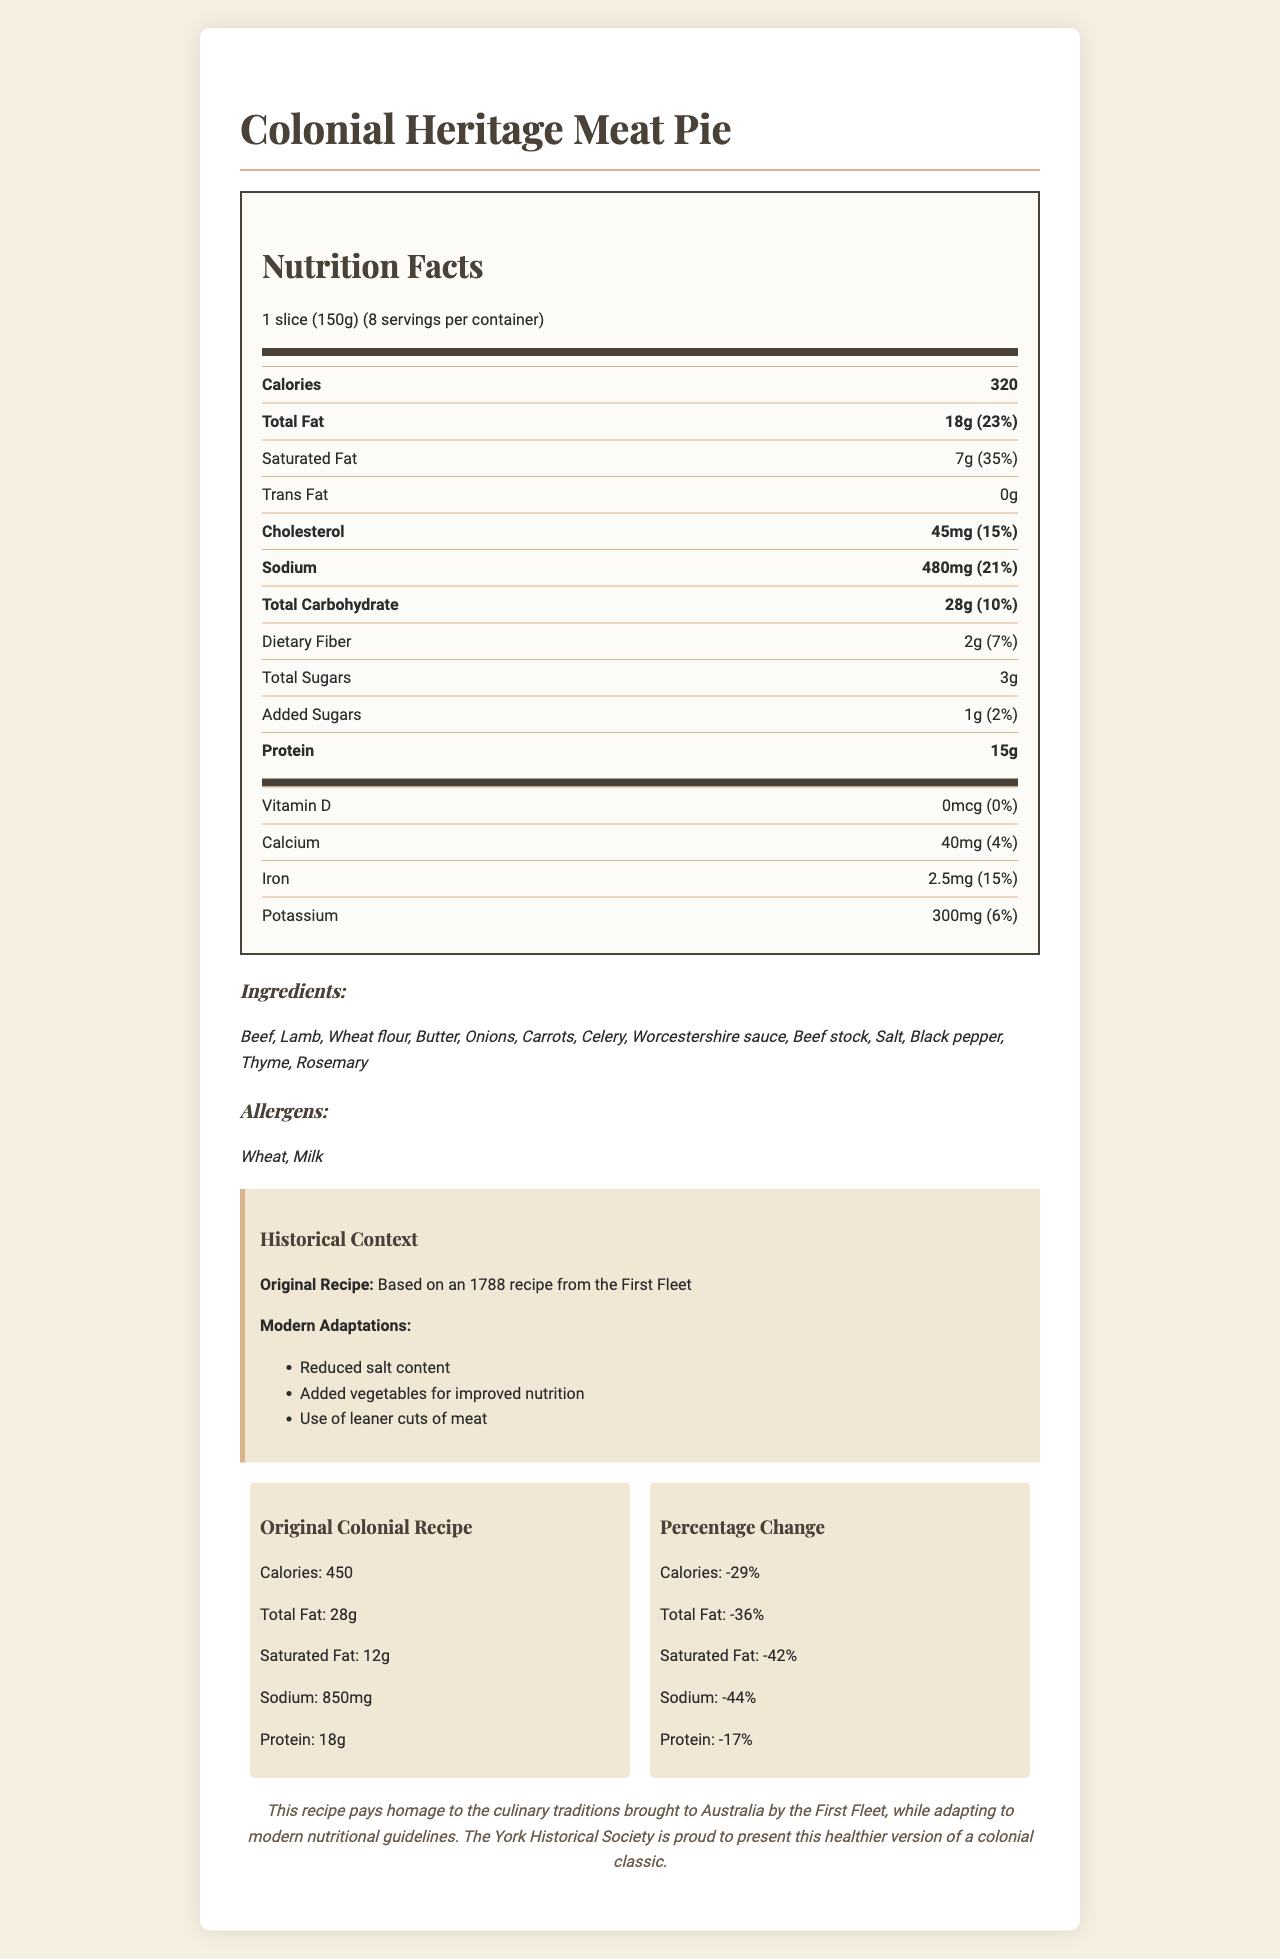what is the serving size of the Colonial Heritage Meat Pie? The serving size is stated as "1 slice (150g)" under the Nutrition Facts heading.
Answer: 1 slice (150g) how many calories are in one serving of the Colonial Heritage Meat Pie? The calories per serving are listed as 320 under the Calories section in the Nutrition Facts.
Answer: 320 how much total fat is in one serving, and what percentage of the daily value does it represent? The Total Fat section of the Nutrition Facts says there are 18g of total fat, which is 23% of the daily value.
Answer: 18g, 23% what is the amount of sodium per serving? The sodium amount is listed as 480mg under the Sodium section in the Nutrition Facts.
Answer: 480mg how much protein is in one serving? The amount of protein per serving is provided as 15g under the Protein section in the Nutrition Facts.
Answer: 15g which of the following modern adaptations were made to the original recipe? A. Increased salt content B. Added vegetables C. Use of fattier cuts of meat The Modern Adaptations section lists "Added vegetables for improved nutrition" as one of the adaptations.
Answer: B how much iron is in one serving of the meat pie? A. 4mg B. 2.5mg C. 10mg The Nutrition Facts show that one serving has 2.5mg of iron.
Answer: B is the new version of the meat pie higher or lower in calories compared to the original colonial recipe? The Comparative Nutrition section states that the original recipe had 450 calories compared to the current recipe's 320 calories, indicating a reduction.
Answer: Lower are there any allergens listed in the ingredients of the Colonial Heritage Meat Pie? The Allergens section lists "Wheat" and "Milk" as allergens in the meat pie.
Answer: Yes summarize the main idea of the document. The document provides comprehensive details about the Colonial Heritage Meat Pie including its nutrition facts, ingredients, historical context, and adaptations made to align with modern nutritional guidelines. It highlights the changes made from the original 1788 recipe, resulting in a pie with lower calories, fats, and sodium.
Answer: The document details the nutritional information for a modern adaptation of a colonial-era meat pie, listing its nutritional content, ingredients, allergens, historical context, and a comparison with the original recipe. what are the three main modern adaptations made to the original recipe? The Historical Context section specifies these three adaptations under Modern Adaptations.
Answer: Reduced salt content, added vegetables for improved nutrition, use of leaner cuts of meat how much lower is the sodium content in the modern meat pie compared to the original recipe, in percentage terms? The Percentage Change section in the Comparative Nutrition reveals a 44% reduction in sodium content.
Answer: 44% how many servings are there in one container of the Colonial Heritage Meat Pie? The document mentions that there are 8 servings per container.
Answer: 8 what is the total carbohydrate content per serving, and what percentage of the daily value does it represent? The Total Carbohydrate section lists 28g and 10% as the carbohydrate content and its daily value percentage respectively.
Answer: 28g, 10% which ingredient is not listed in the Colonial Heritage Meat Pie? A. Thyme B. Rosemary C. Garlic The Ingredients section lists Thyme and Rosemary but not Garlic.
Answer: C what historical recipe is this modern adaptation based on? This information is provided in the Historical Context section as "Based on an 1788 recipe from the First Fleet".
Answer: Based on an 1788 recipe from the First Fleet does the new recipe include vitamin D? The Nutrition Facts indicate that the amount of Vitamin D is 0mcg, which is 0% of the daily value, implying absence of vitamin D.
Answer: No are there any details about the production date of the Colonial Heritage Meat Pie? The document does not provide any details about the production date of the meat pie.
Answer: Not enough information 